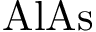Convert formula to latex. <formula><loc_0><loc_0><loc_500><loc_500>{ A l A s }</formula> 